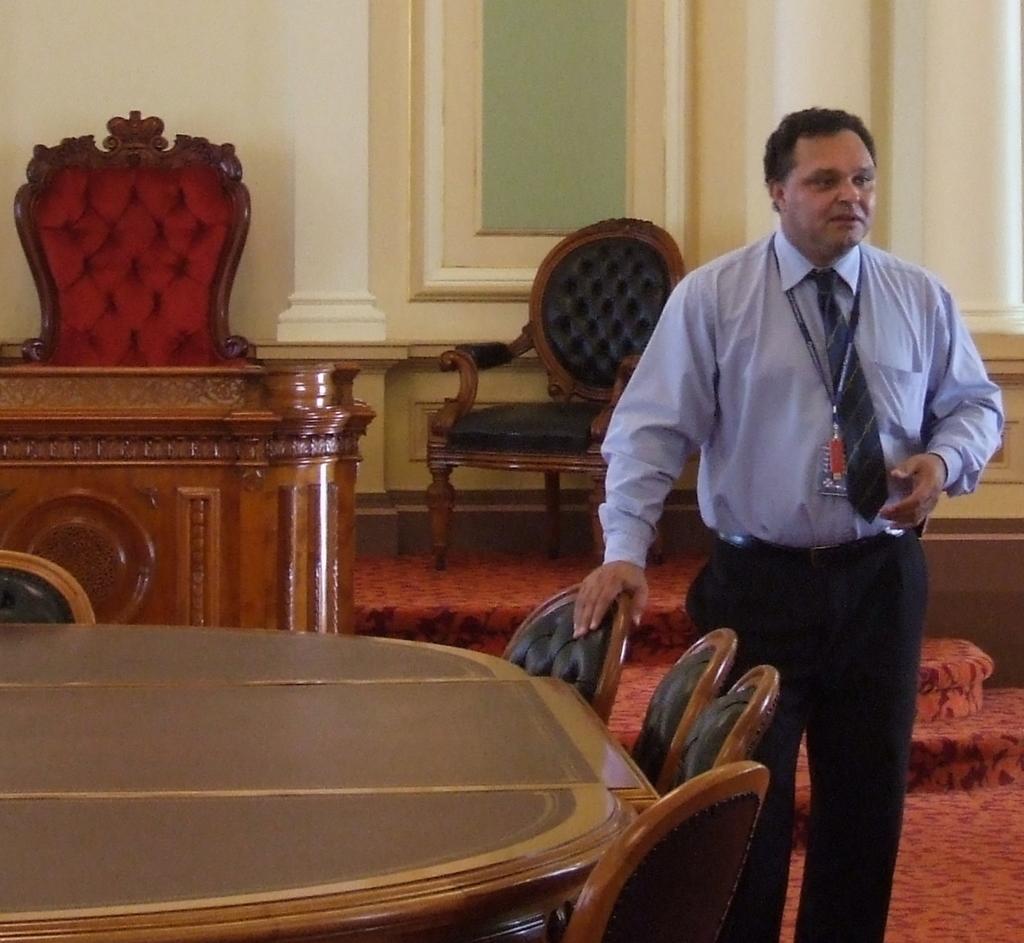Can you describe this image briefly? In this picture we can see a man who is standing on the floor. This is the table and these are the chairs. And in the background we can see the wall and this is the window. 